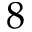Convert formula to latex. <formula><loc_0><loc_0><loc_500><loc_500>8</formula> 